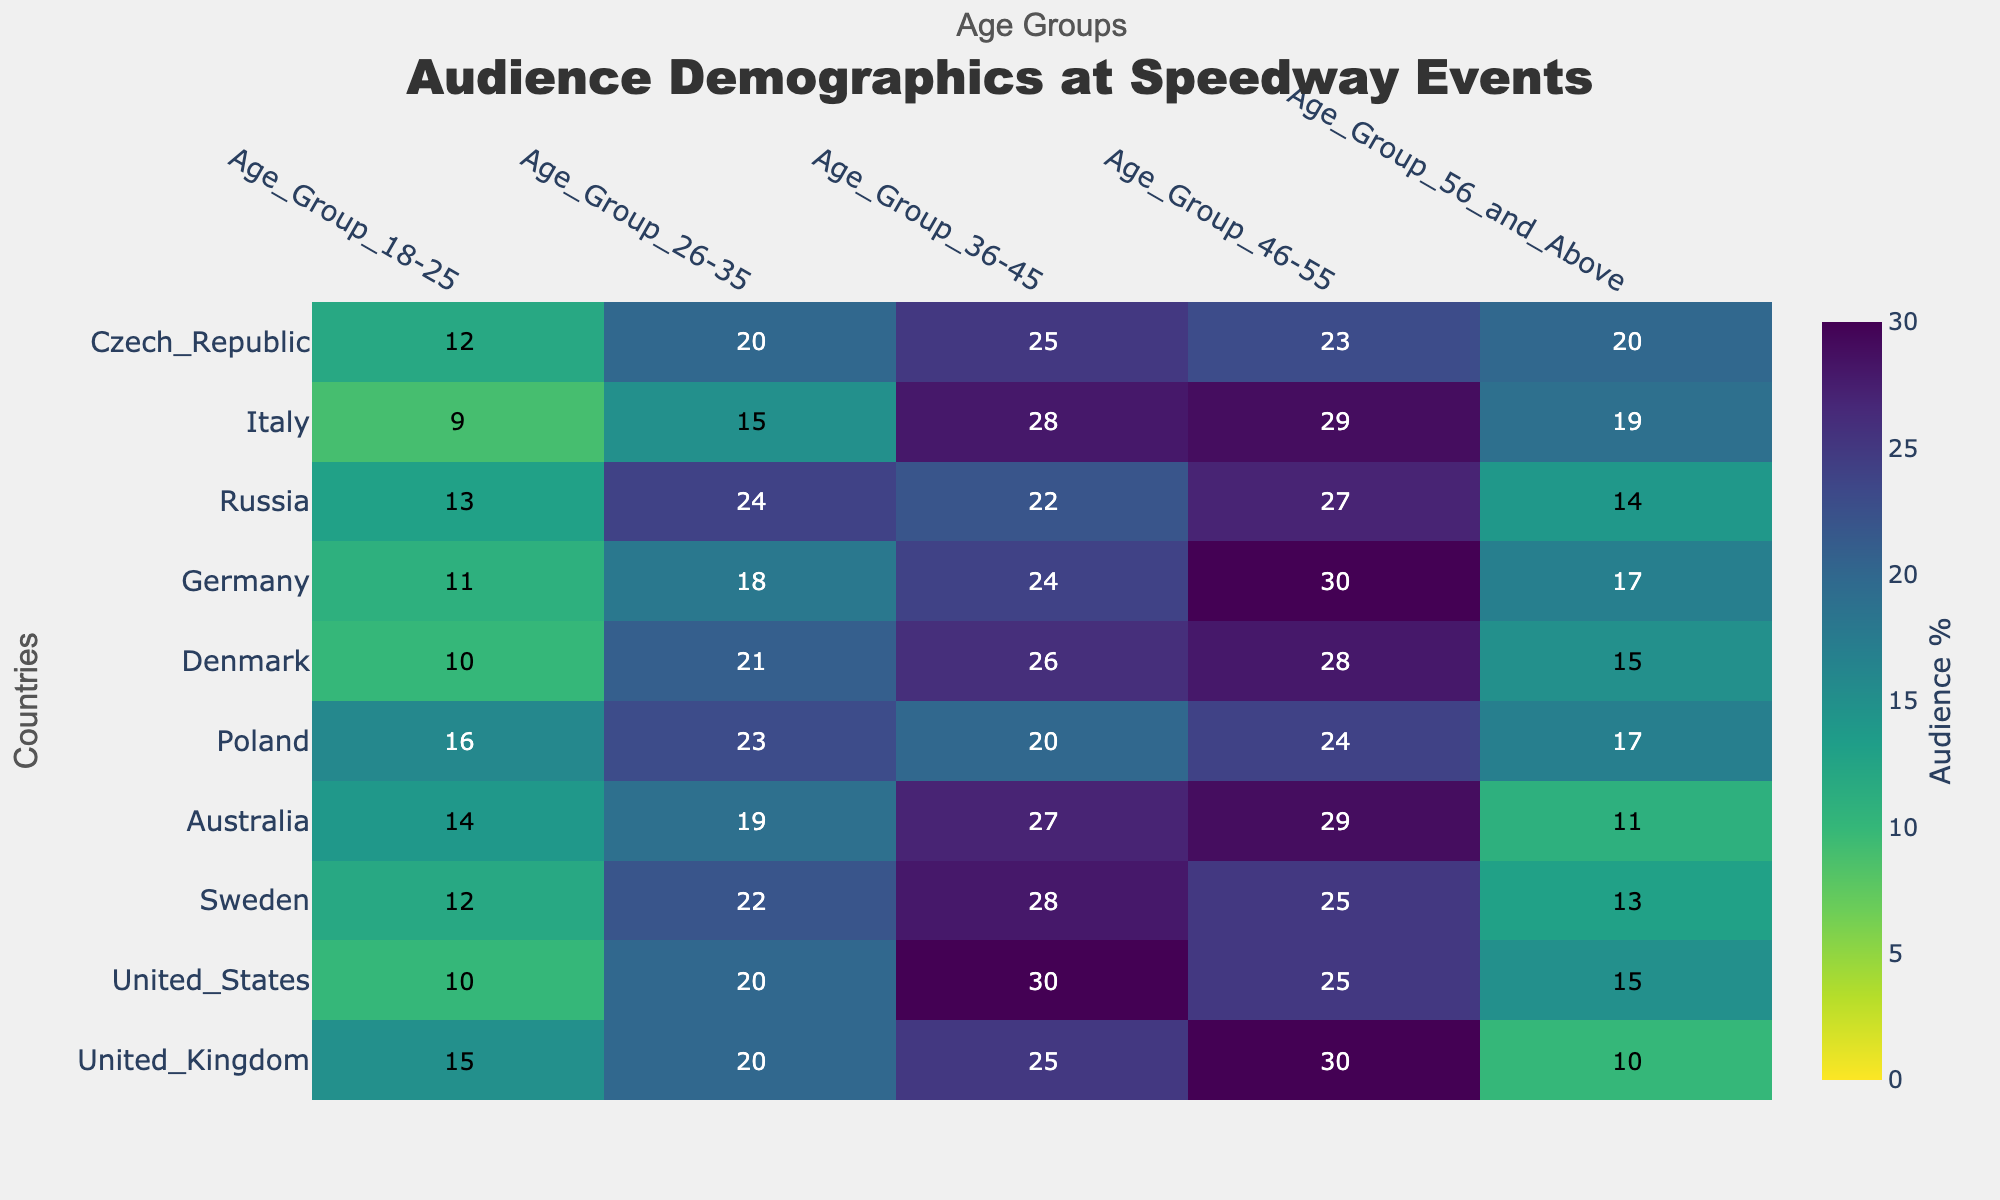What's the title of the figure? The title of the figure is displayed prominently at the top of the heatmap. It should be easily visible.
Answer: Audience Demographics at Speedway Events What are the countries listed on the y-axis? The countries are listed vertically on the y-axis. By reading from top to bottom, you can list them.
Answer: United Kingdom, United States, Sweden, Australia, Poland, Denmark, Germany, Russia, Italy, Czech Republic Which age group has the highest audience percentage for Australia? Locate "Australia" on the y-axis, then move horizontally to find the highest value within its row.
Answer: Age Group 46-55 How does the audience percentage in the 18-25 age group for Germany compare to that for Poland? Locate Germany and Poland on the y-axis, then find the corresponding values in the 18-25 age group for both. Compare these values.
Answer: Germany has a lower percentage (11) compared to Poland (16) Which age group generally has the lowest audience percentage across all countries? Compare the values in each age group column and identify which group's minimum value appears most frequently across countries.
Answer: Age Group 18-25 What is the sum of the audience percentages for the 36-45 age group in Sweden and Denmark? Locate Sweden and Denmark on the y-axis, note the values in the 36-45 age group and then add them together.
Answer: 28 (Sweden) + 26 (Denmark) = 54 Is there any age group where the audience percentage in the United States exceeds that of all other countries? Compare the values for the United States in each age group to the values for all other countries in the respective age group. Check if any age group has the highest value for the United States.
Answer: Yes, Age Group 36-45 Which country has the smallest audience percentage in the 56 and above age group? Identify the values in the 56 and above age group column and find the minimum value; then, match it to the corresponding country.
Answer: Australia In which age group does Russia have its highest audience percentage? Locate Russia on the y-axis and find the highest value within its row to determine the corresponding age group.
Answer: Age Group 26-35 